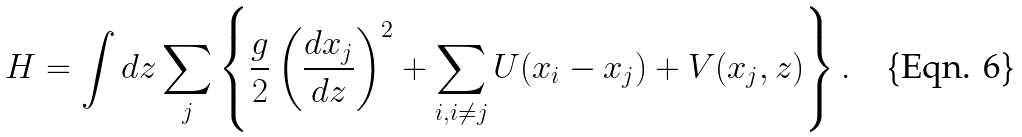Convert formula to latex. <formula><loc_0><loc_0><loc_500><loc_500>H = \int d z \sum _ { j } \left \{ \frac { g } { 2 } \left ( \frac { d x _ { j } } { d z } \right ) ^ { 2 } + \sum _ { i , i \neq j } U ( x _ { i } - x _ { j } ) + V ( x _ { j } , z ) \right \} .</formula> 